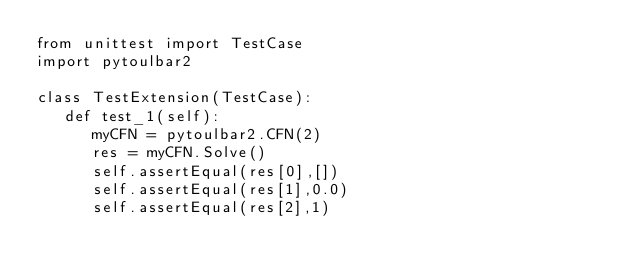Convert code to text. <code><loc_0><loc_0><loc_500><loc_500><_Python_>from unittest import TestCase
import pytoulbar2

class TestExtension(TestCase):
   def test_1(self):
      myCFN = pytoulbar2.CFN(2)
      res = myCFN.Solve()
      self.assertEqual(res[0],[])
      self.assertEqual(res[1],0.0)
      self.assertEqual(res[2],1)
 
</code> 